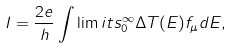Convert formula to latex. <formula><loc_0><loc_0><loc_500><loc_500>I = \frac { 2 e } { h } \int \lim i t s _ { 0 } ^ { \infty } \Delta T ( E ) f _ { \mu } d E ,</formula> 